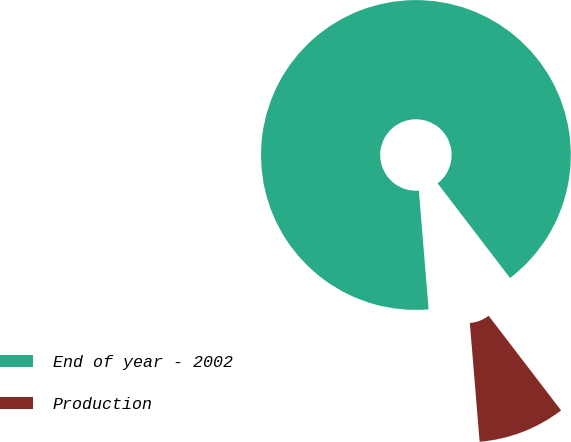<chart> <loc_0><loc_0><loc_500><loc_500><pie_chart><fcel>End of year - 2002<fcel>Production<nl><fcel>90.91%<fcel>9.09%<nl></chart> 